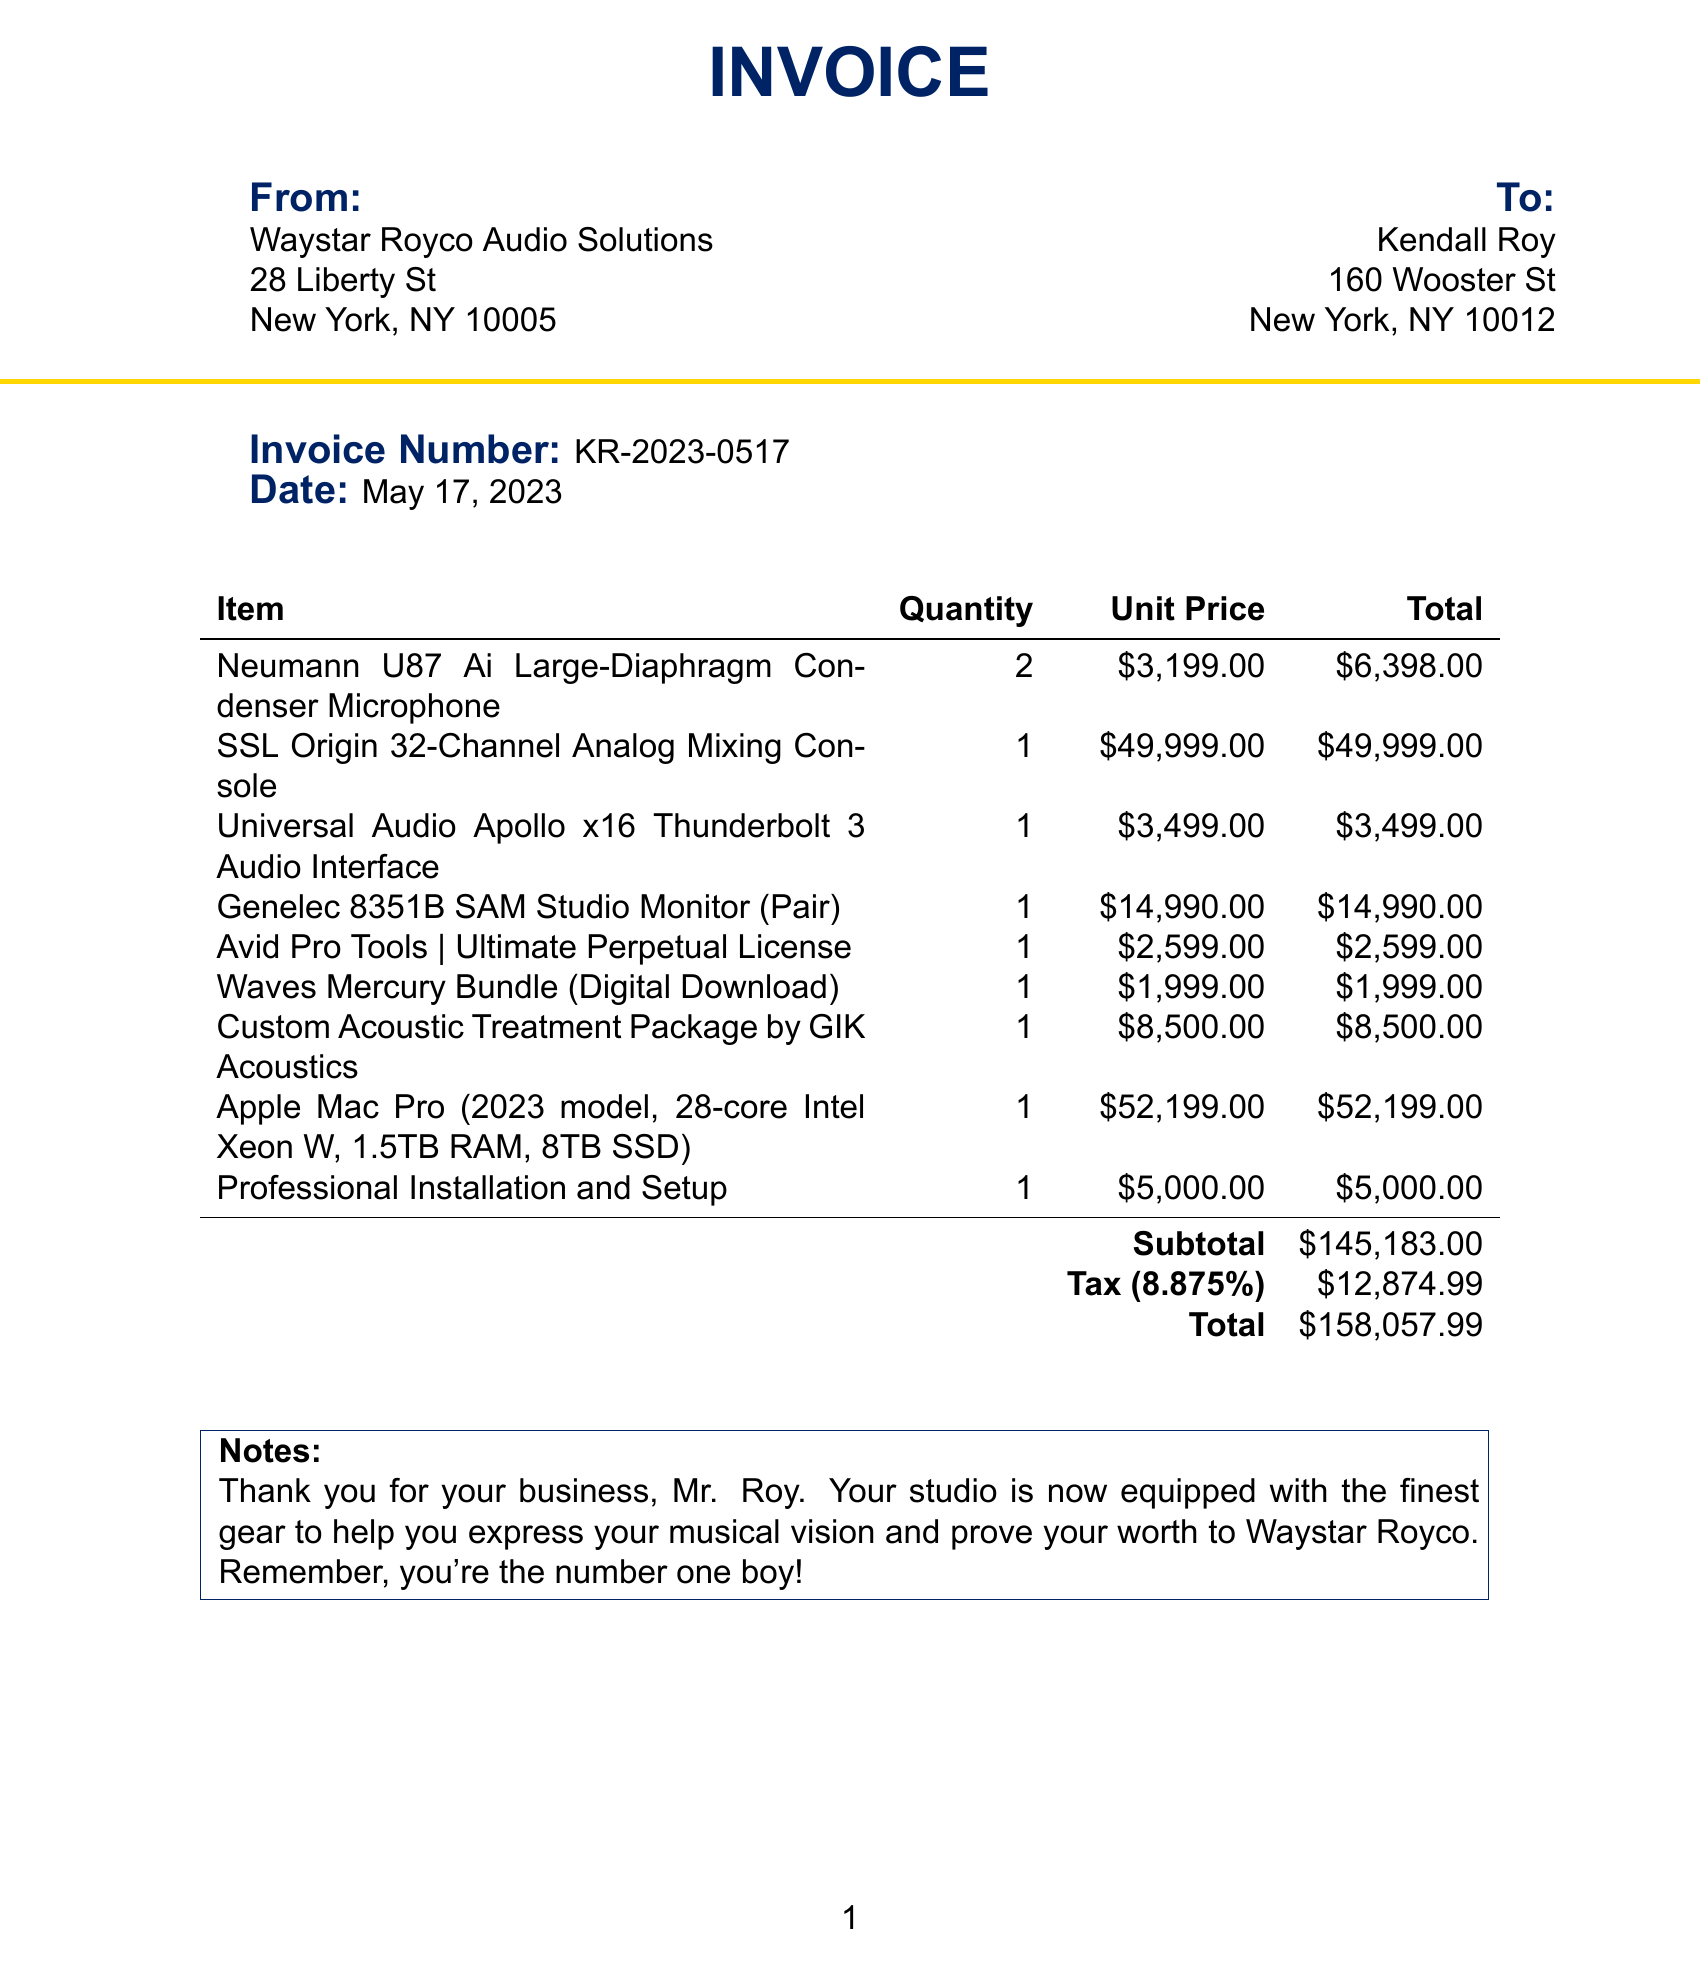What is the invoice number? The invoice number is prominently displayed in the document.
Answer: KR-2023-0517 Who is the customer? The customer name is specified at the top of the invoice.
Answer: Kendall Roy What is the total amount due? The total amount is calculated at the bottom of the invoice, including tax and subtotal.
Answer: $158,057.99 How many Neumann U87 microphones did Kendall order? The quantity of Neumann U87 microphones is listed in the item section of the invoice.
Answer: 2 What is the subtotal before tax? The subtotal is provided just before the tax amount in the calculations.
Answer: $145,183.00 What type of item is the SSL Origin? The SSL Origin is described in the items section with its type and function.
Answer: Mixing Console How much was charged for professional installation and setup? This charge is listed as a separate line item in the invoice details.
Answer: $5,000.00 What is the tax rate applied to the invoice? The tax rate is mentioned in the subtotal calculations of the document.
Answer: 8.875% What is the model of the computer purchased? The name of the computer is included with detail in the item list.
Answer: Apple Mac Pro (2023 model, 28-core Intel Xeon W, 1.5TB RAM, 8TB SSD) 